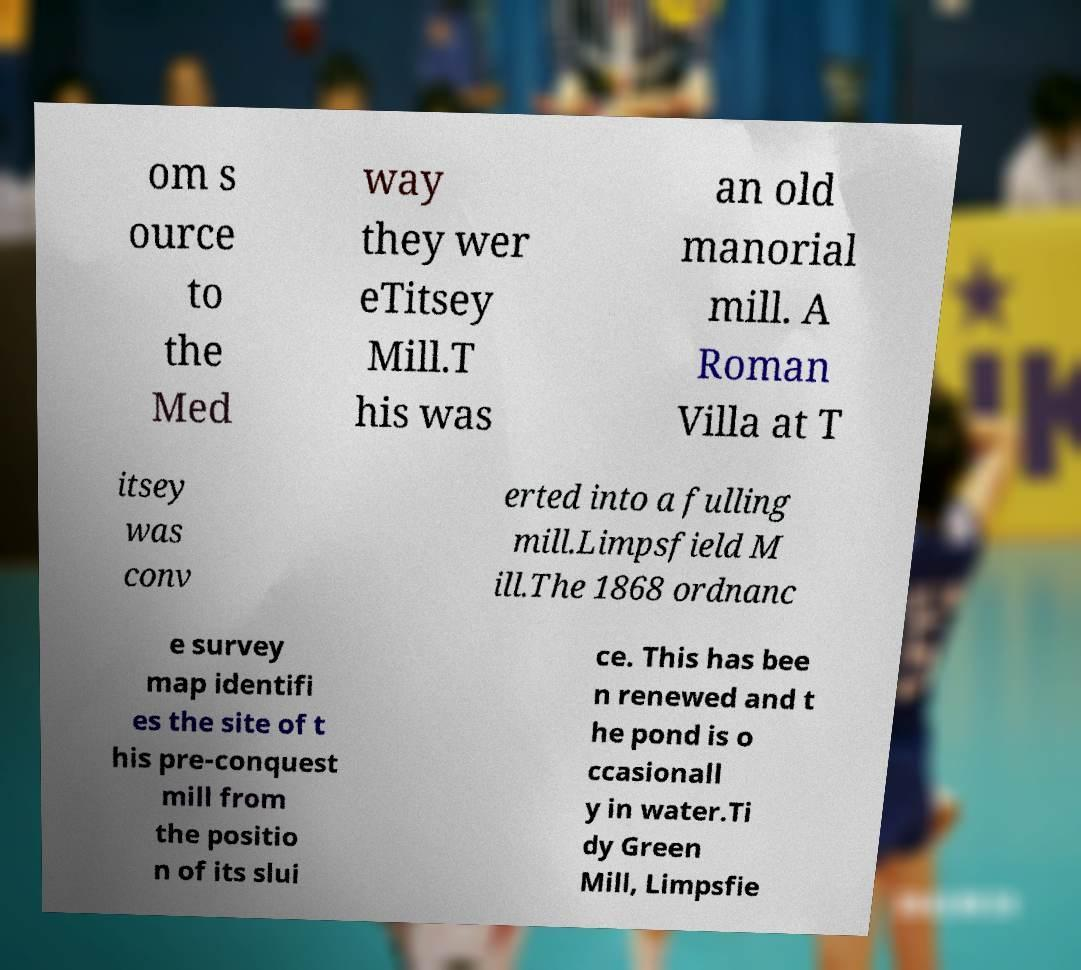Could you extract and type out the text from this image? om s ource to the Med way they wer eTitsey Mill.T his was an old manorial mill. A Roman Villa at T itsey was conv erted into a fulling mill.Limpsfield M ill.The 1868 ordnanc e survey map identifi es the site of t his pre-conquest mill from the positio n of its slui ce. This has bee n renewed and t he pond is o ccasionall y in water.Ti dy Green Mill, Limpsfie 